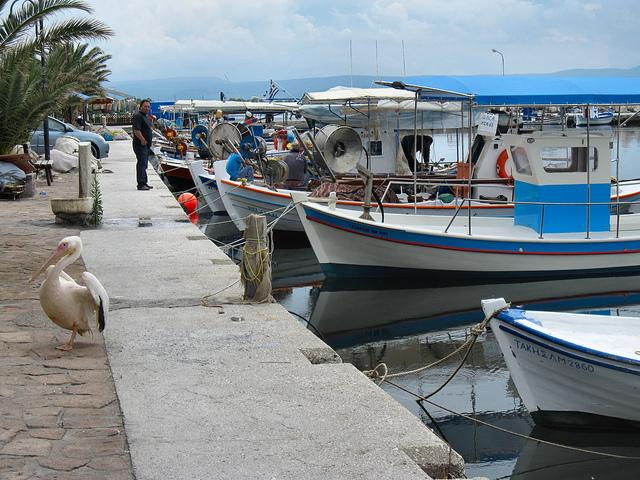What is the name of the large bird? Please explain your reasoning. stork. The bird has a long, pointed beak. 